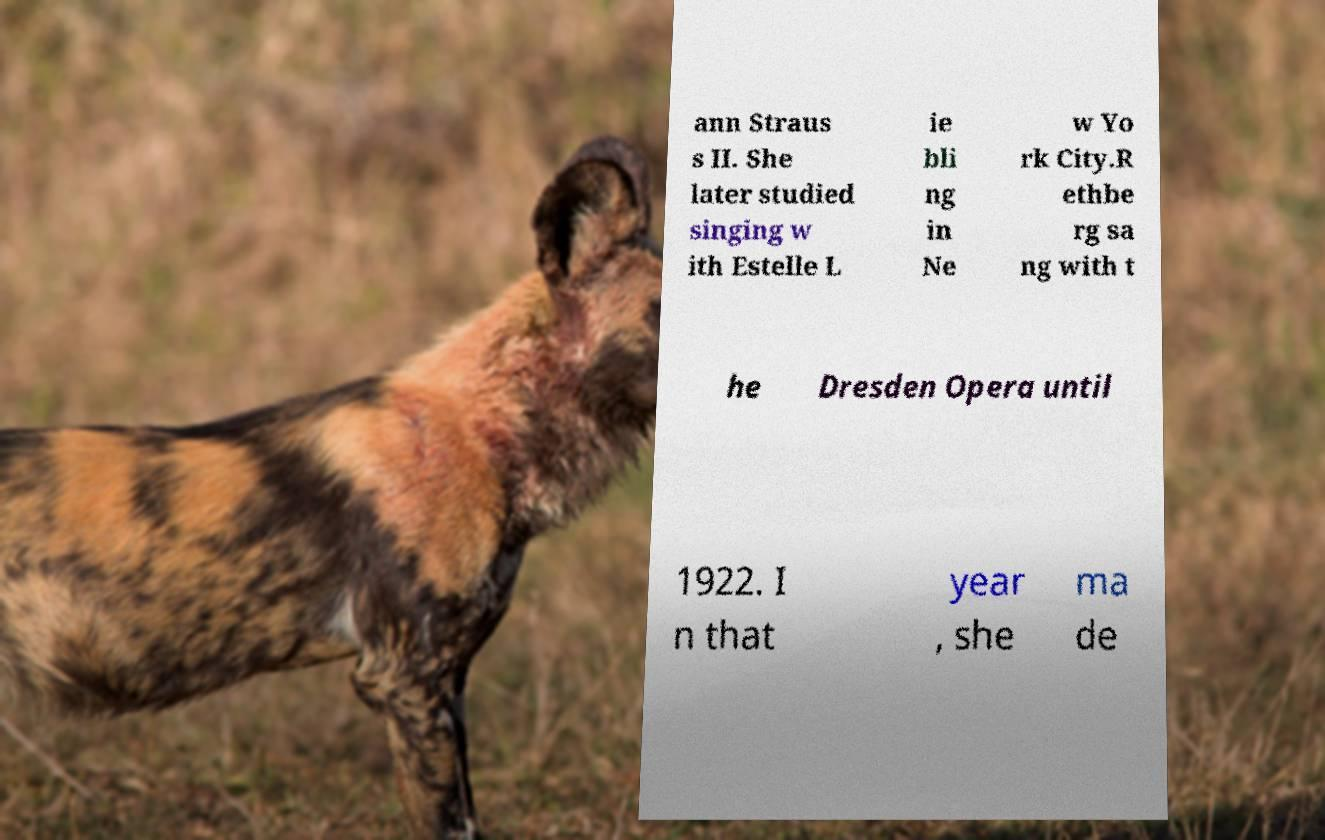There's text embedded in this image that I need extracted. Can you transcribe it verbatim? ann Straus s II. She later studied singing w ith Estelle L ie bli ng in Ne w Yo rk City.R ethbe rg sa ng with t he Dresden Opera until 1922. I n that year , she ma de 